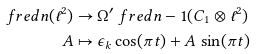<formula> <loc_0><loc_0><loc_500><loc_500>\ f r e d { n } ( \ell ^ { 2 } ) & \to \Omega ^ { \prime } \ f r e d { n - 1 } ( C _ { 1 } \otimes \ell ^ { 2 } ) \\ A & \mapsto \epsilon _ { k } \cos ( \pi t ) + A \, \sin ( \pi t )</formula> 